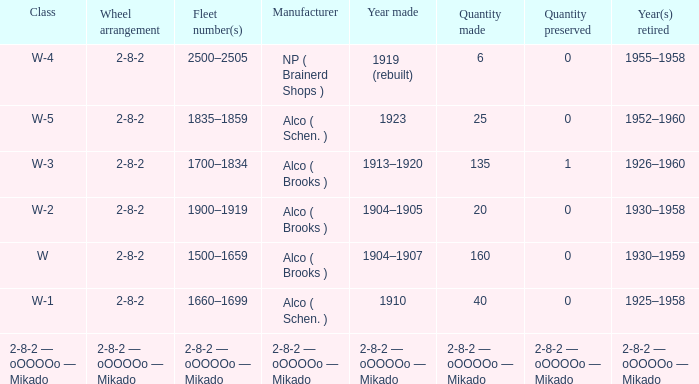What is the locomotive class that has a wheel arrangement of 2-8-2 and a quantity made of 25? W-5. 